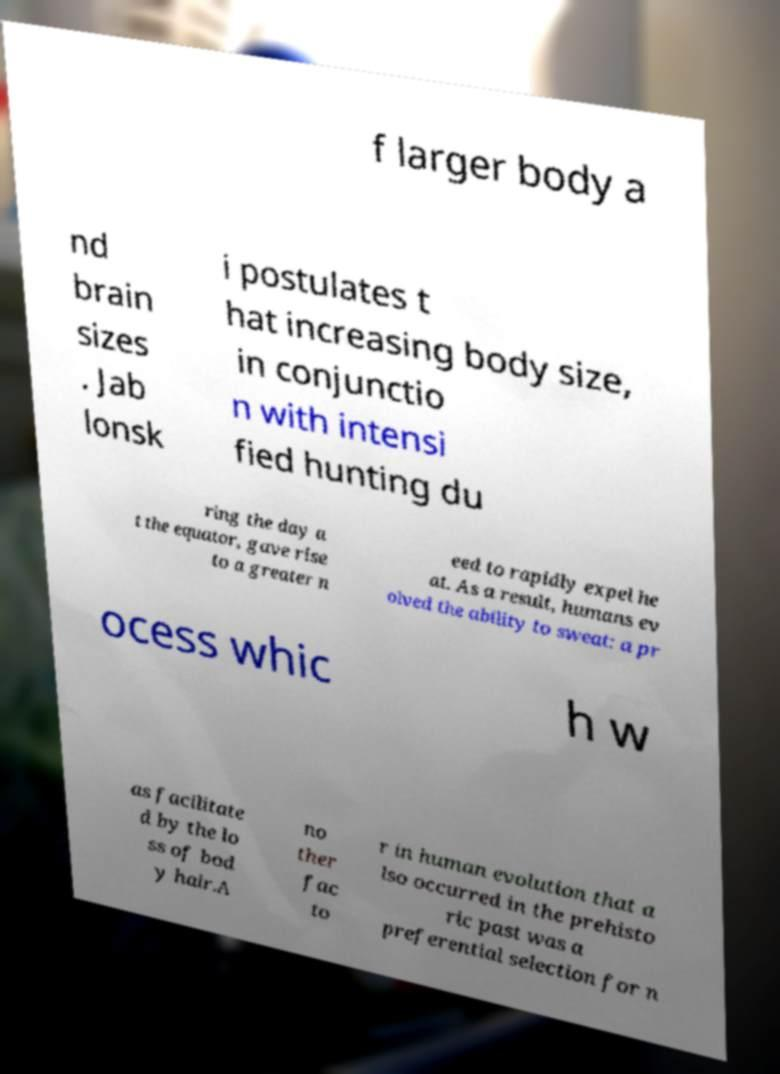For documentation purposes, I need the text within this image transcribed. Could you provide that? f larger body a nd brain sizes . Jab lonsk i postulates t hat increasing body size, in conjunctio n with intensi fied hunting du ring the day a t the equator, gave rise to a greater n eed to rapidly expel he at. As a result, humans ev olved the ability to sweat: a pr ocess whic h w as facilitate d by the lo ss of bod y hair.A no ther fac to r in human evolution that a lso occurred in the prehisto ric past was a preferential selection for n 